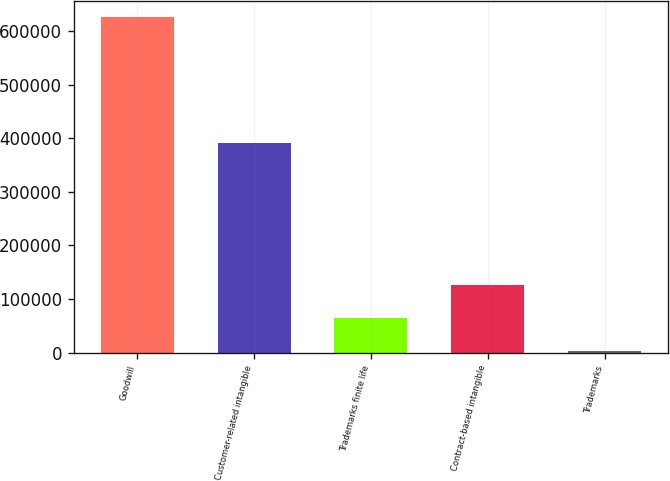Convert chart. <chart><loc_0><loc_0><loc_500><loc_500><bar_chart><fcel>Goodwill<fcel>Customer-related intangible<fcel>Trademarks finite life<fcel>Contract-based intangible<fcel>Trademarks<nl><fcel>625120<fcel>390232<fcel>64846.6<fcel>127099<fcel>2594<nl></chart> 